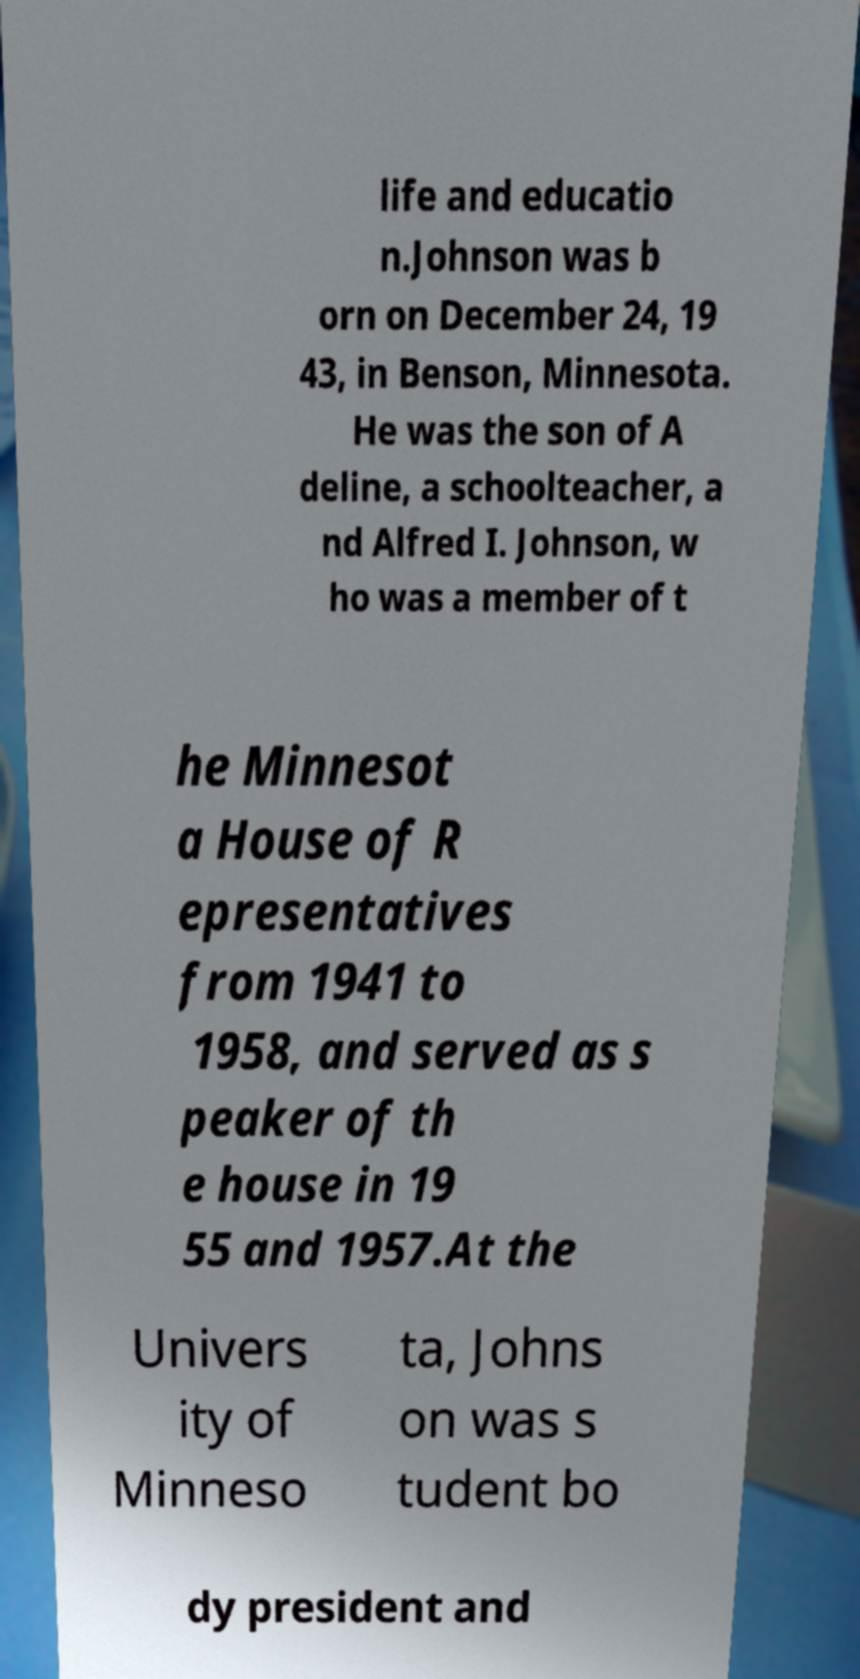Could you assist in decoding the text presented in this image and type it out clearly? life and educatio n.Johnson was b orn on December 24, 19 43, in Benson, Minnesota. He was the son of A deline, a schoolteacher, a nd Alfred I. Johnson, w ho was a member of t he Minnesot a House of R epresentatives from 1941 to 1958, and served as s peaker of th e house in 19 55 and 1957.At the Univers ity of Minneso ta, Johns on was s tudent bo dy president and 